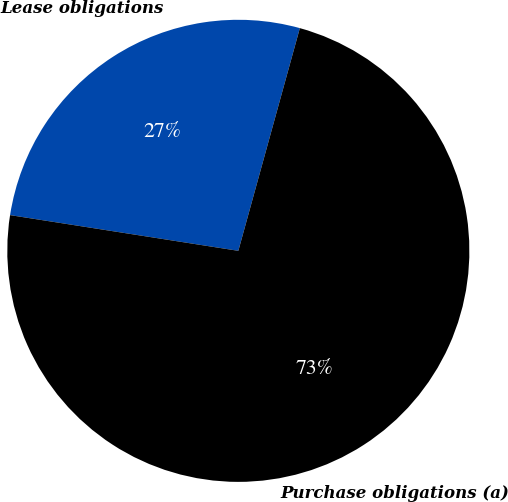Convert chart to OTSL. <chart><loc_0><loc_0><loc_500><loc_500><pie_chart><fcel>Lease obligations<fcel>Purchase obligations (a)<nl><fcel>26.82%<fcel>73.18%<nl></chart> 